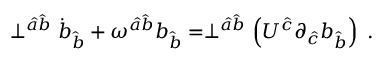Convert formula to latex. <formula><loc_0><loc_0><loc_500><loc_500>\perp ^ { \hat { a } \hat { b } } \dot { b } _ { \hat { b } } + { \omega } ^ { \hat { a } \hat { b } } b _ { \hat { b } } = \perp ^ { \hat { a } \hat { b } } \left ( U ^ { \hat { c } } \partial _ { \hat { c } } b _ { \hat { b } } \right ) \, .</formula> 